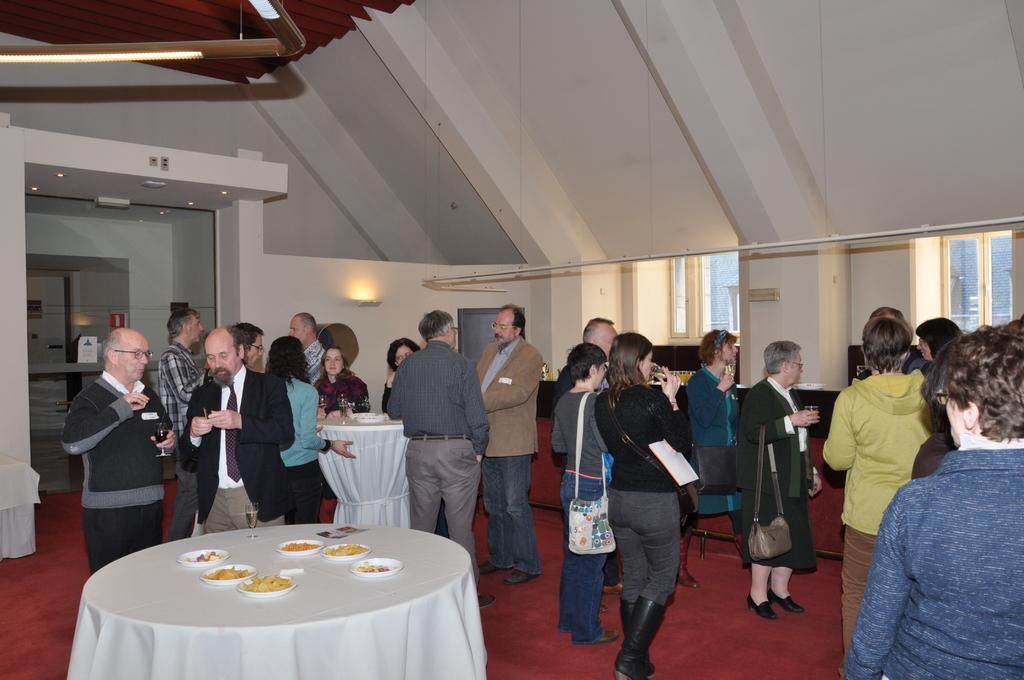Describe this image in one or two sentences. In the image there are many people stood on red carpet,this seems to in a party ,In front there is a table with food. 